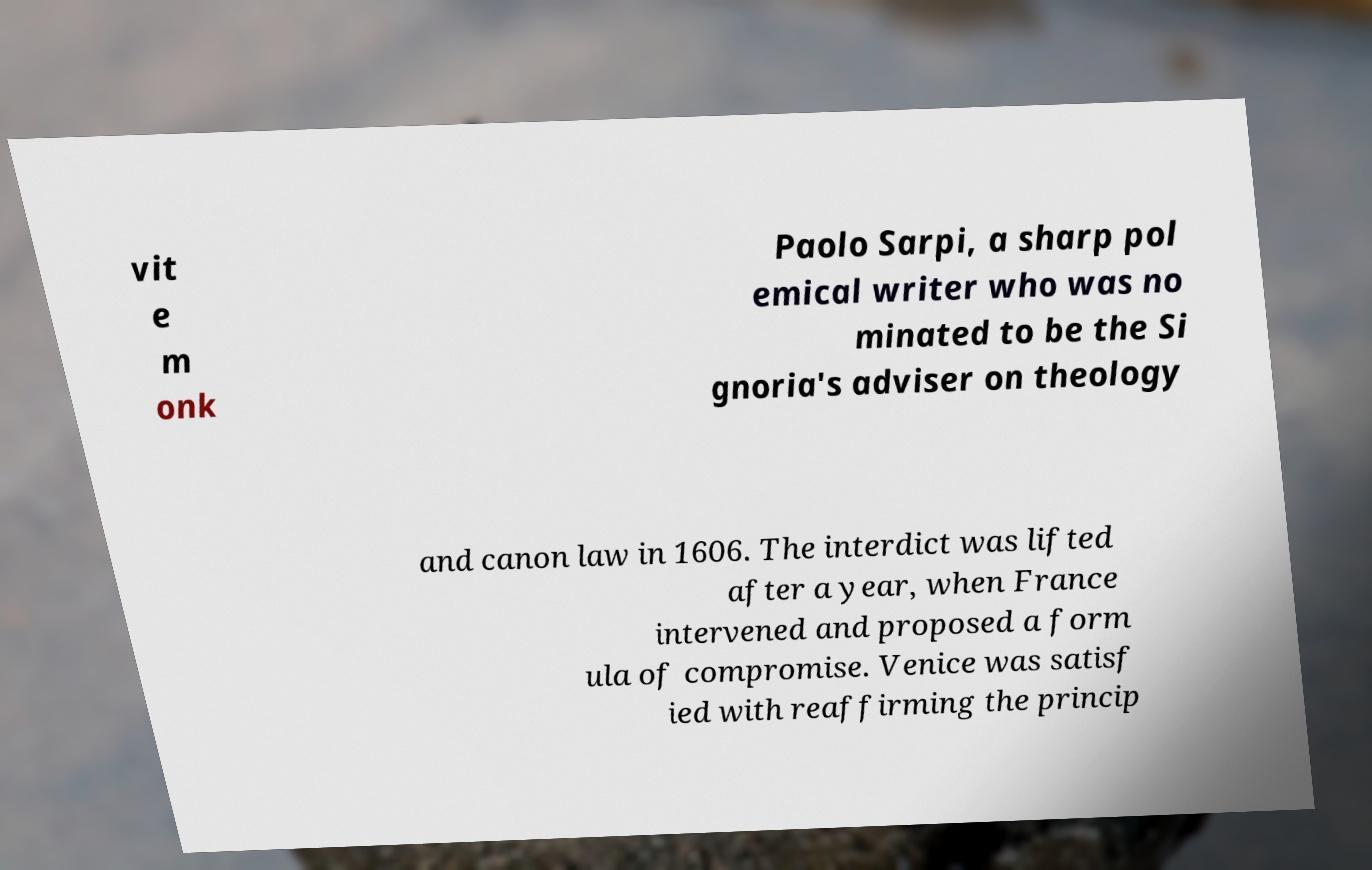Please read and relay the text visible in this image. What does it say? vit e m onk Paolo Sarpi, a sharp pol emical writer who was no minated to be the Si gnoria's adviser on theology and canon law in 1606. The interdict was lifted after a year, when France intervened and proposed a form ula of compromise. Venice was satisf ied with reaffirming the princip 